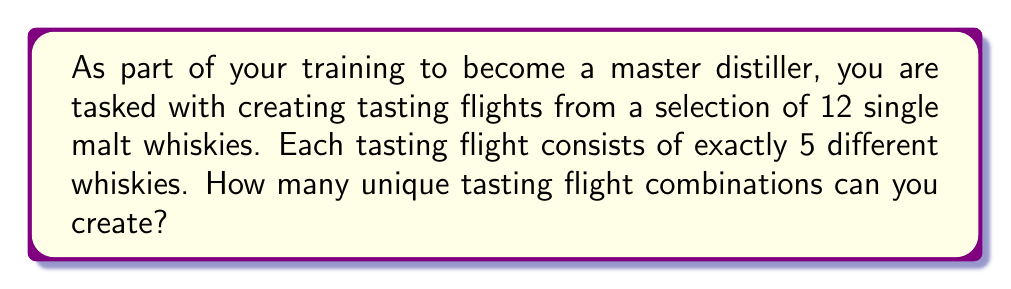Can you solve this math problem? To solve this problem, we need to use the combination formula from combinatorics. Here's the step-by-step explanation:

1. We have a total of 12 single malt whiskies to choose from.
2. We need to select 5 whiskies for each tasting flight.
3. The order of selection doesn't matter (e.g., selecting whisky A then B is the same as selecting B then A).
4. We are not allowed to repeat whiskies in a single flight.

This scenario fits the definition of a combination problem. We use the combination formula:

$$ C(n,r) = \binom{n}{r} = \frac{n!}{r!(n-r)!} $$

Where:
$n$ = total number of items to choose from (12 whiskies)
$r$ = number of items being chosen (5 whiskies per flight)

Plugging in our values:

$$ C(12,5) = \binom{12}{5} = \frac{12!}{5!(12-5)!} = \frac{12!}{5!7!} $$

Calculating this:

$$ \frac{12 * 11 * 10 * 9 * 8 * 7!}{(5 * 4 * 3 * 2 * 1) * 7!} = \frac{95040}{120} = 792 $$

Therefore, the number of unique tasting flight combinations is 792.
Answer: 792 